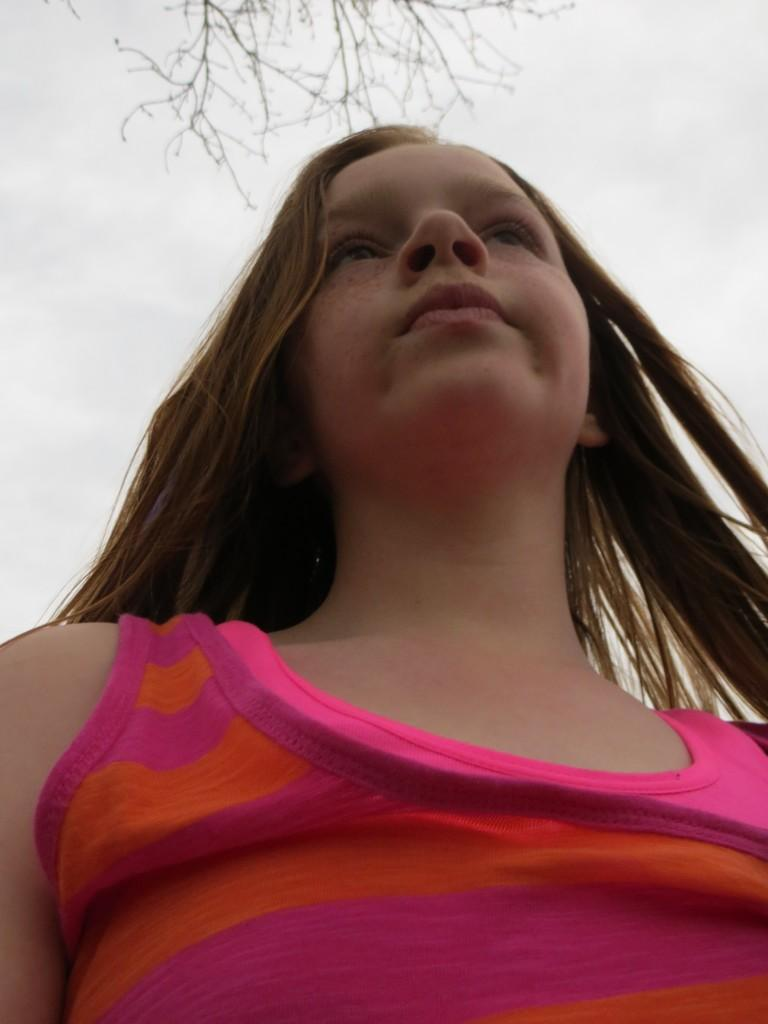What is the main subject of the image? There is a person in the image, but they are truncated. What can be seen in the background of the image? There are branches and the sky visible in the background of the image. What type of pipe can be seen in the image? There is no pipe present in the image. Can you describe the sea visible in the image? There is no sea present in the image; it features a person and a background with branches and the sky. 